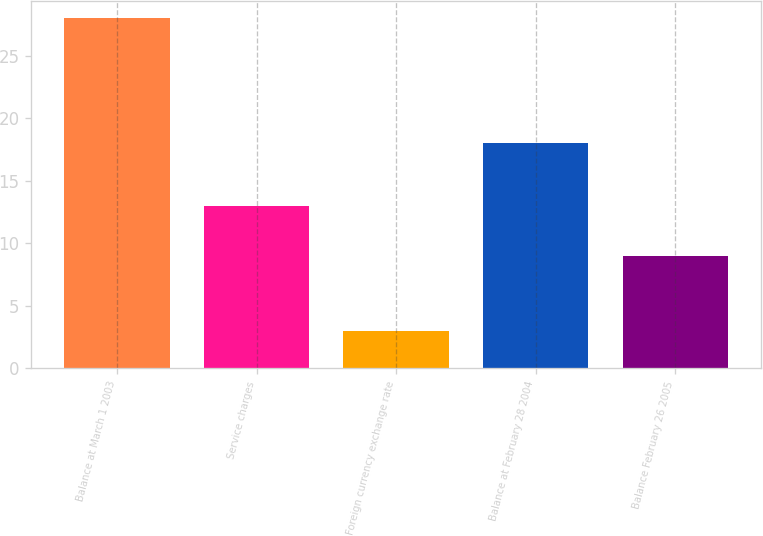<chart> <loc_0><loc_0><loc_500><loc_500><bar_chart><fcel>Balance at March 1 2003<fcel>Service charges<fcel>Foreign currency exchange rate<fcel>Balance at February 28 2004<fcel>Balance February 26 2005<nl><fcel>28<fcel>13<fcel>3<fcel>18<fcel>9<nl></chart> 